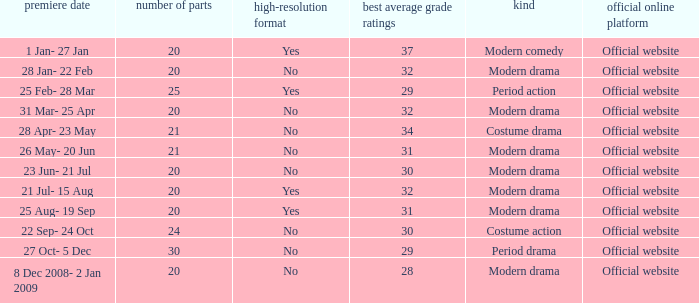Can you give me this table as a dict? {'header': ['premiere date', 'number of parts', 'high-resolution format', 'best average grade ratings', 'kind', 'official online platform'], 'rows': [['1 Jan- 27 Jan', '20', 'Yes', '37', 'Modern comedy', 'Official website'], ['28 Jan- 22 Feb', '20', 'No', '32', 'Modern drama', 'Official website'], ['25 Feb- 28 Mar', '25', 'Yes', '29', 'Period action', 'Official website'], ['31 Mar- 25 Apr', '20', 'No', '32', 'Modern drama', 'Official website'], ['28 Apr- 23 May', '21', 'No', '34', 'Costume drama', 'Official website'], ['26 May- 20 Jun', '21', 'No', '31', 'Modern drama', 'Official website'], ['23 Jun- 21 Jul', '20', 'No', '30', 'Modern drama', 'Official website'], ['21 Jul- 15 Aug', '20', 'Yes', '32', 'Modern drama', 'Official website'], ['25 Aug- 19 Sep', '20', 'Yes', '31', 'Modern drama', 'Official website'], ['22 Sep- 24 Oct', '24', 'No', '30', 'Costume action', 'Official website'], ['27 Oct- 5 Dec', '30', 'No', '29', 'Period drama', 'Official website'], ['8 Dec 2008- 2 Jan 2009', '20', 'No', '28', 'Modern drama', 'Official website']]} What was the airing date when the number of episodes was larger than 20 and had the genre of costume action? 22 Sep- 24 Oct. 